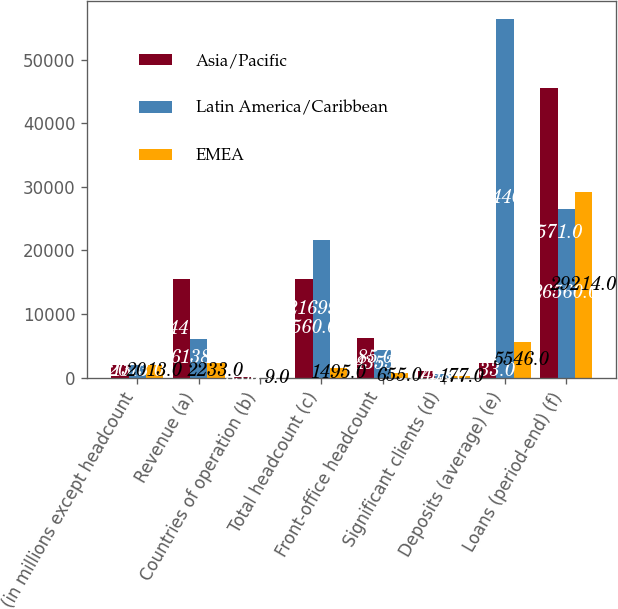Convert chart. <chart><loc_0><loc_0><loc_500><loc_500><stacked_bar_chart><ecel><fcel>(in millions except headcount<fcel>Revenue (a)<fcel>Countries of operation (b)<fcel>Total headcount (c)<fcel>Front-office headcount<fcel>Significant clients (d)<fcel>Deposits (average) (e)<fcel>Loans (period-end) (f)<nl><fcel>Asia/Pacific<fcel>2013<fcel>15441<fcel>33<fcel>15560<fcel>6285<fcel>1071<fcel>2233<fcel>45571<nl><fcel>Latin America/Caribbean<fcel>2013<fcel>6138<fcel>17<fcel>21699<fcel>4353<fcel>498<fcel>56440<fcel>26560<nl><fcel>EMEA<fcel>2013<fcel>2233<fcel>9<fcel>1495<fcel>655<fcel>177<fcel>5546<fcel>29214<nl></chart> 